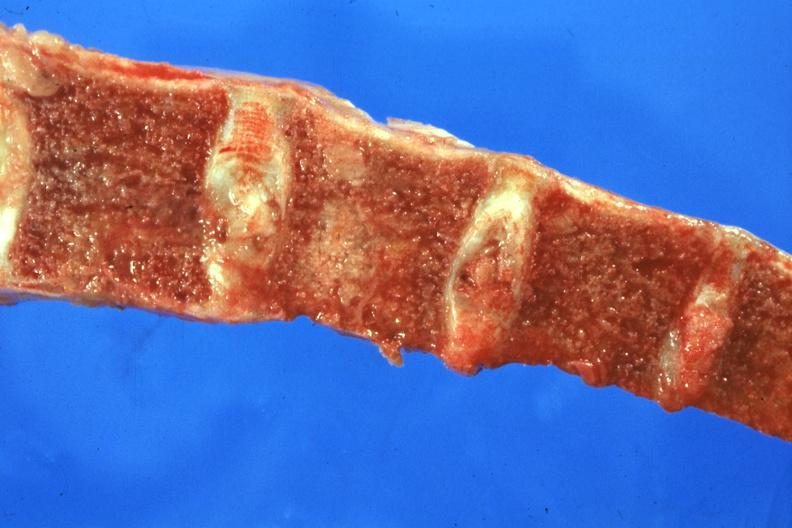how many nodules does this image show sectioned bone with of tumor?
Answer the question using a single word or phrase. Two 